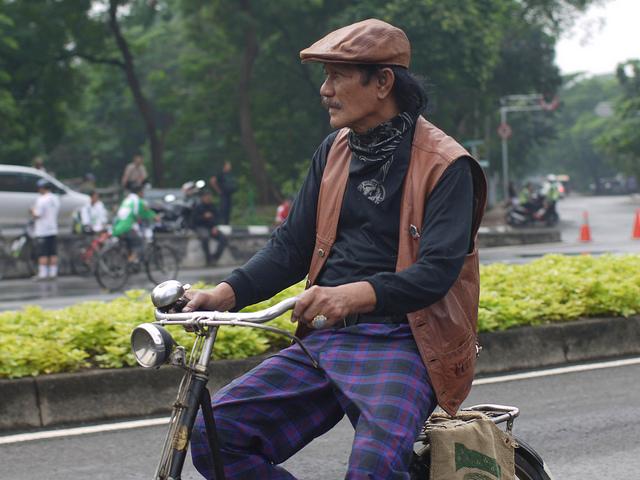Does the man have a mustache?
Be succinct. Yes. What is the man riding?
Write a very short answer. Bicycle. Does this man have plaid pants on?
Keep it brief. Yes. 